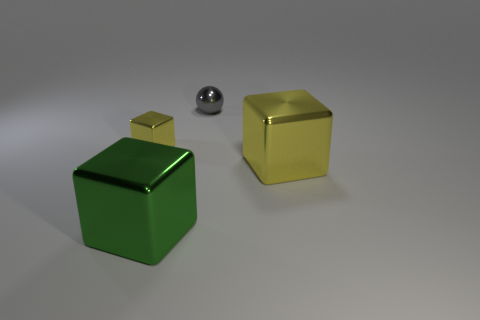Is there anything else that has the same shape as the gray object?
Your response must be concise. No. Is there a metallic thing that has the same size as the metallic ball?
Make the answer very short. Yes. The tiny thing that is behind the yellow shiny thing that is on the left side of the green metal block is what color?
Provide a short and direct response. Gray. What number of big yellow metallic blocks are there?
Offer a very short reply. 1. Is the number of yellow metallic objects that are right of the small ball less than the number of shiny blocks right of the tiny yellow thing?
Provide a short and direct response. Yes. The small metal ball has what color?
Your answer should be compact. Gray. What number of other metal cubes have the same color as the small shiny cube?
Your answer should be compact. 1. There is a big yellow cube; are there any big yellow shiny objects to the right of it?
Your answer should be compact. No. Are there an equal number of metallic things that are right of the large green metallic thing and metal things in front of the small yellow metal object?
Ensure brevity in your answer.  Yes. There is a yellow thing on the right side of the large green metallic object; is its size the same as the yellow cube left of the gray object?
Ensure brevity in your answer.  No. 